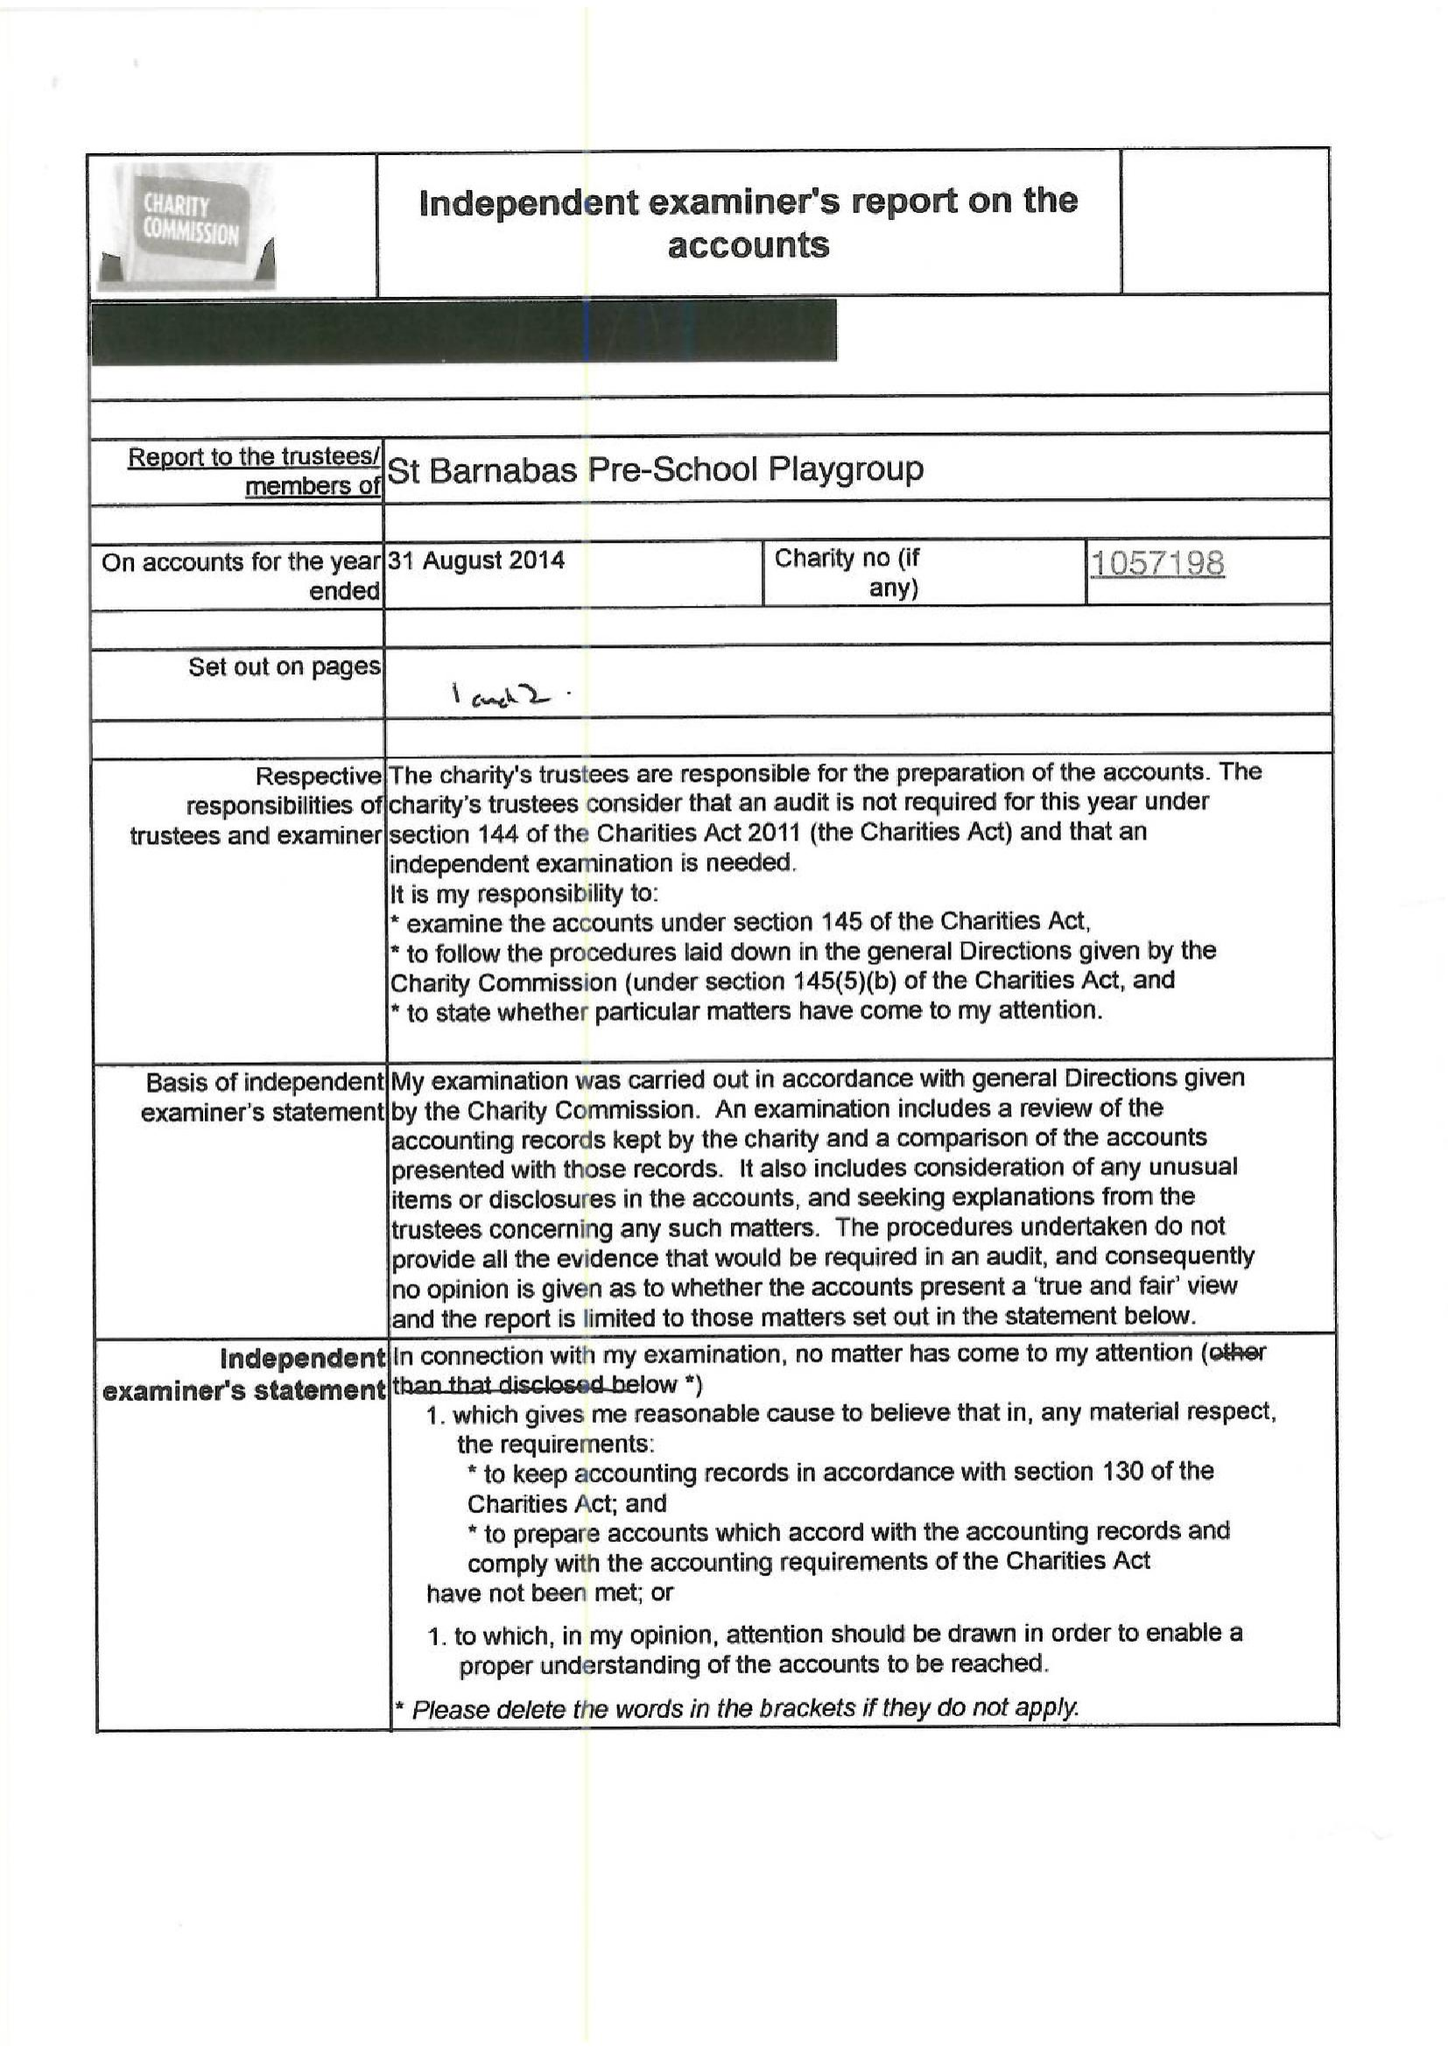What is the value for the charity_name?
Answer the question using a single word or phrase. St Barnabas Pre School Playgroup 